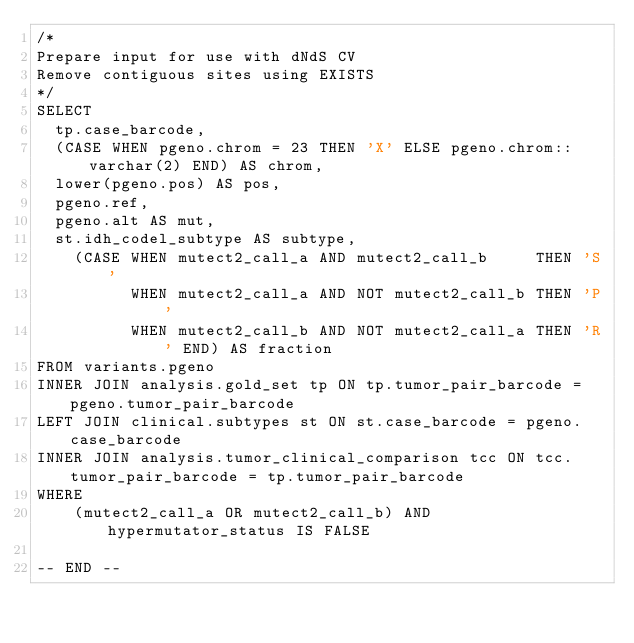Convert code to text. <code><loc_0><loc_0><loc_500><loc_500><_SQL_>/*
Prepare input for use with dNdS CV
Remove contiguous sites using EXISTS
*/
SELECT
  tp.case_barcode,
  (CASE WHEN pgeno.chrom = 23 THEN 'X' ELSE pgeno.chrom::varchar(2) END) AS chrom,
  lower(pgeno.pos) AS pos,
  pgeno.ref,
  pgeno.alt AS mut,
  st.idh_codel_subtype AS subtype,
    (CASE WHEN mutect2_call_a AND mutect2_call_b     THEN 'S'
          WHEN mutect2_call_a AND NOT mutect2_call_b THEN 'P'
          WHEN mutect2_call_b AND NOT mutect2_call_a THEN 'R' END) AS fraction
FROM variants.pgeno
INNER JOIN analysis.gold_set tp ON tp.tumor_pair_barcode = pgeno.tumor_pair_barcode
LEFT JOIN clinical.subtypes st ON st.case_barcode = pgeno.case_barcode
INNER JOIN analysis.tumor_clinical_comparison tcc ON tcc.tumor_pair_barcode = tp.tumor_pair_barcode
WHERE
    (mutect2_call_a OR mutect2_call_b) AND hypermutator_status IS FALSE
    
-- END --</code> 